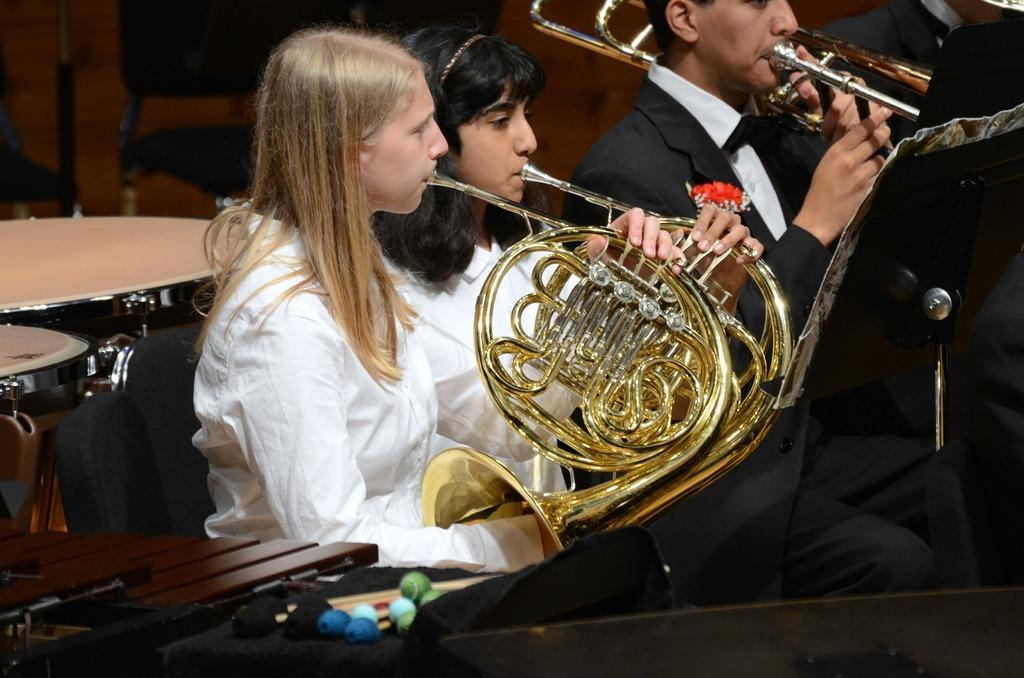What are the people in the image doing? The people in the image are playing musical instruments. What can be seen in the image besides the people playing instruments? There is a stand and drums visible in the image. What is in the background of the image? There are chairs in the background of the image. What type of lettuce is being served as a side dish during the meal in the image? There is no meal or lettuce present in the image; it features people playing musical instruments and related equipment. 